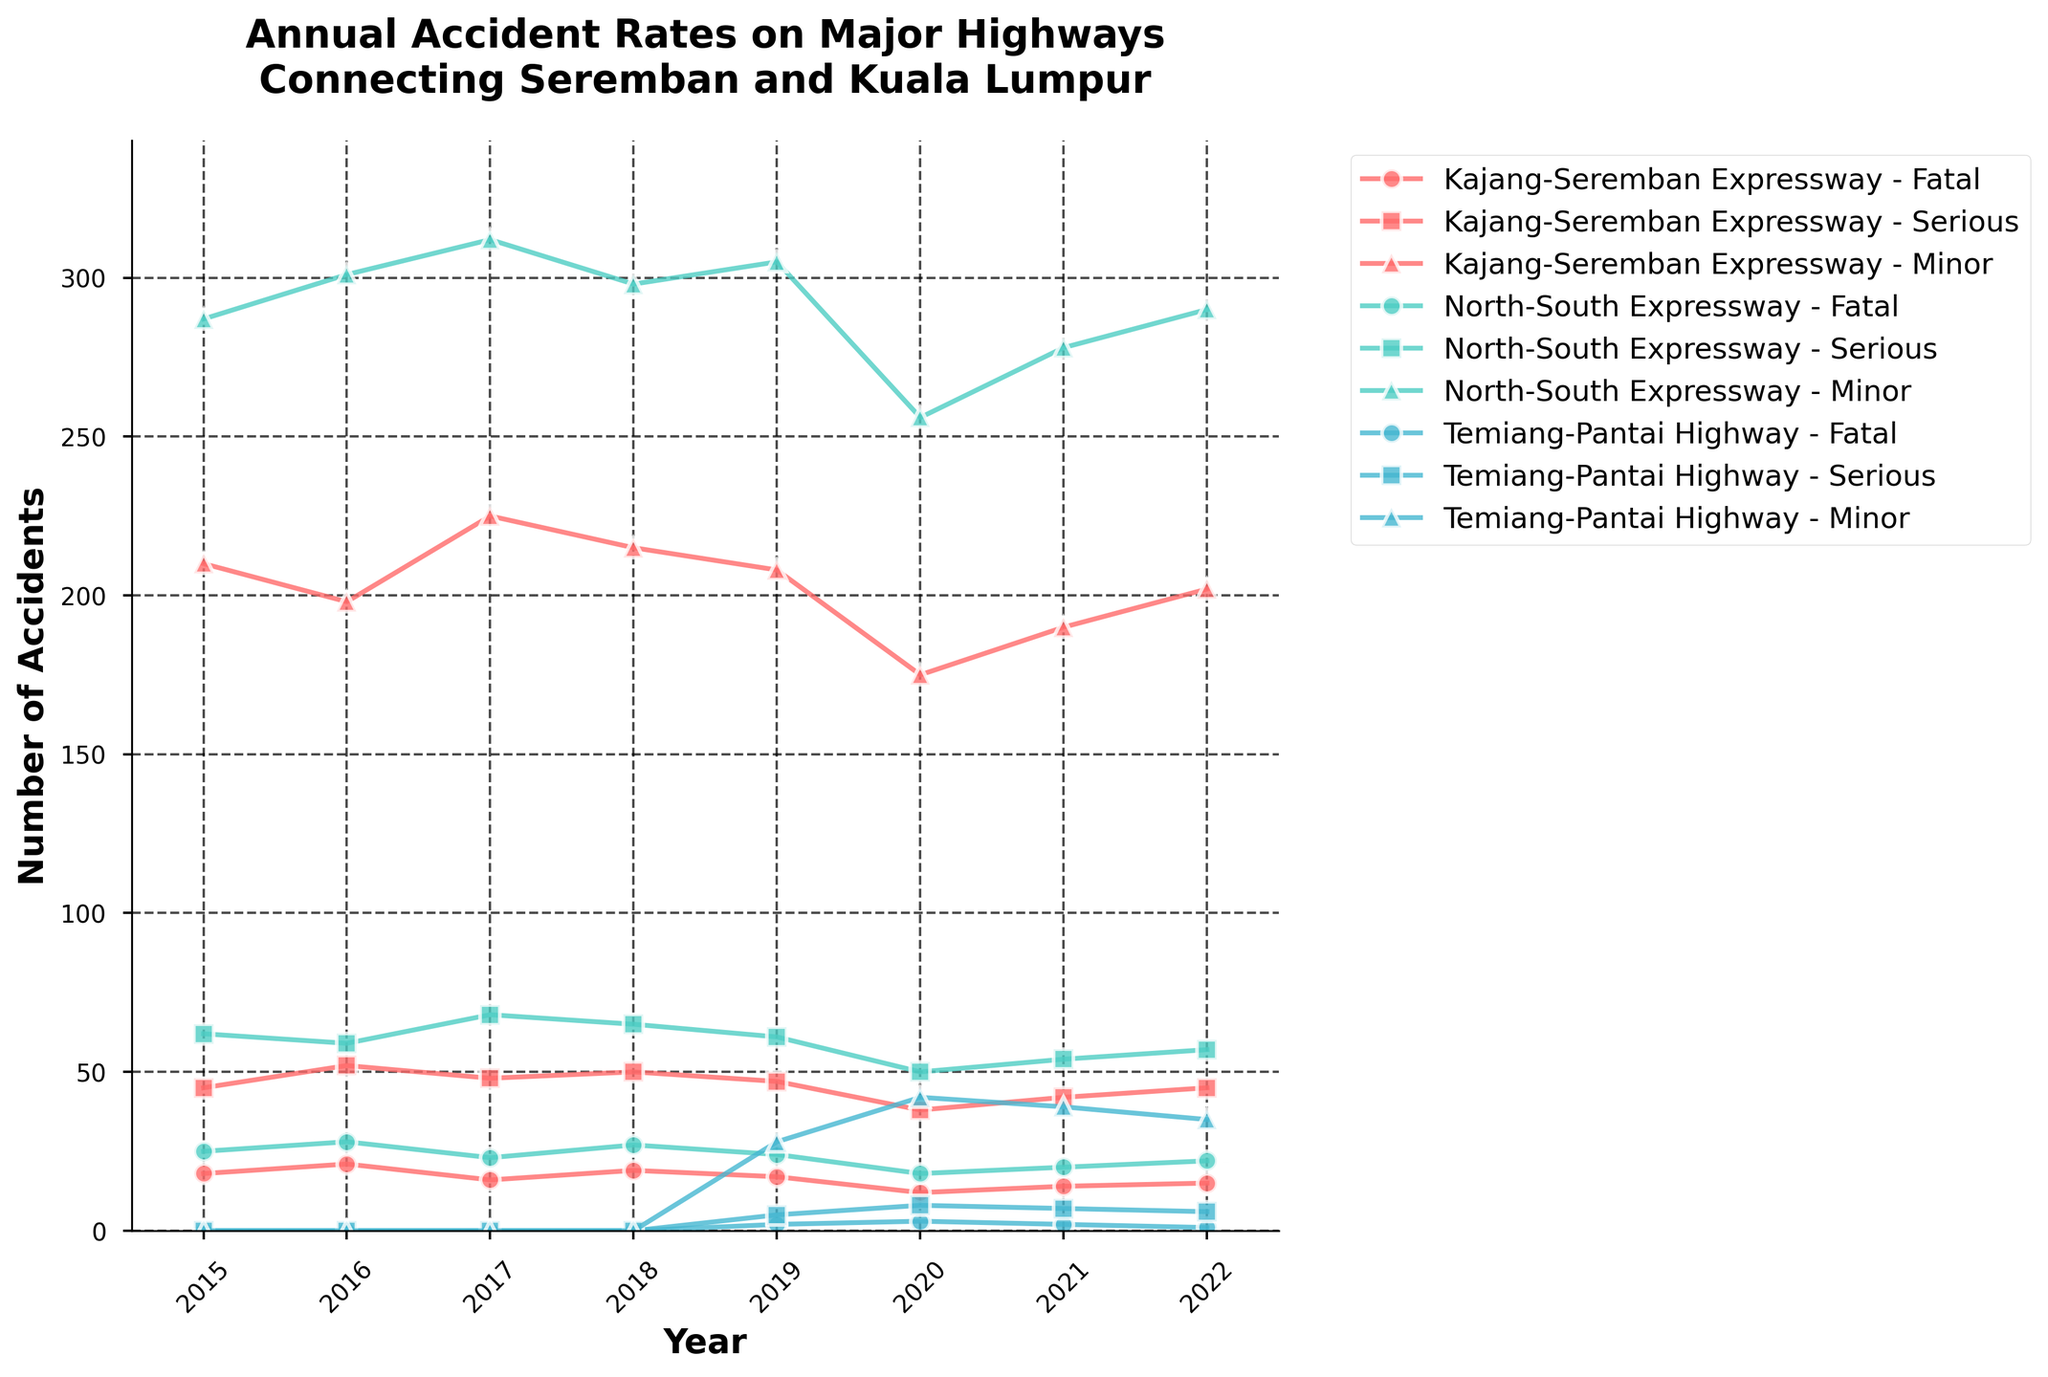What year showed the highest number of minor accidents on the Kajang-Seremban Expressway? Check the values for minor accidents on the Kajang-Seremban Expressway across all the years in the chart. The highest number is 225 in 2017.
Answer: 2017 Compare the number of fatal accidents in 2020 on the North-South Expressway and Temiang-Pantai Highway. Which one is higher and by how much? For 2020, the North-South Expressway has 18 fatal accidents while the Temiang-Pantai Highway has 3 fatal accidents. 18 is higher than 3 by 15.
Answer: North-South Expressway by 15 In which year did the Temiang-Pantai Highway report its first accidents? Look for the earliest year where non-zero values appear for any category of accidents on the Temiang-Pantai Highway. The first appearance is in 2019.
Answer: 2019 Sum the total number of serious accidents on the Kajang-Seremban Expressway across all the years. Sum the serious accidents from 2015 to 2022 on the Kajang-Seremban Expressway. \( 45 + 52 + 48 + 50 + 47 + 38 + 42 + 45 = 367 \)
Answer: 367 Which highway had the smallest number of minor accidents in 2022 and what was that number? Compare the minor accident values for all highways in 2022. The smallest number is 35 on the Temiang-Pantai Highway.
Answer: Temiang-Pantai Highway, 35 What was the trend in the number of fatal accidents on the North-South Expressway from 2015 to 2022? Observe the changes in the number of fatal accidents on the North-South Expressway from 2015 to 2022. The numbers are: 25, 28, 23, 27, 24, 18, 20, 22. The number generally decreases, with slight fluctuations.
Answer: Generally decreasing Which highway experienced the highest increase in serious accidents from 2019 to 2020? Calculate the increase in serious accidents for each highway from 2019 to 2020. Kajang-Seremban Expressway: \( 38 - 47 = -9 \), North-South Expressway: \( 50 - 61 = -11 \), Temiang-Pantai Highway: \( 8 - 5 = 3 \). The highest increase is on the Temiang-Pantai Highway with an increase of 3.
Answer: Temiang-Pantai Highway What is the visual distinction of the markers representing minor accidents on the Kajang-Seremban Expressway? Look at the plotted chart to identify the visual attributes of the markers. Minor accidents on the Kajang-Seremban Expressway are represented by markers shaped like circles.
Answer: Circles Find the average number of minor accidents per year on the North-South Expressway from 2015 to 2022. Calculate the average for minor accidents on the North-South Expressway. \( \frac{287 + 301 + 312 + 298 + 305 + 256 + 278 + 290}{8} = 290.875 \approx 291 \)
Answer: 291 